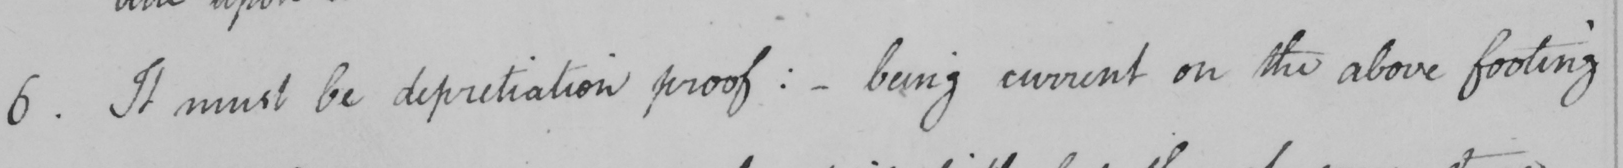What text is written in this handwritten line? 6 . It must be depretiation proof :   _  being current on the above footing 